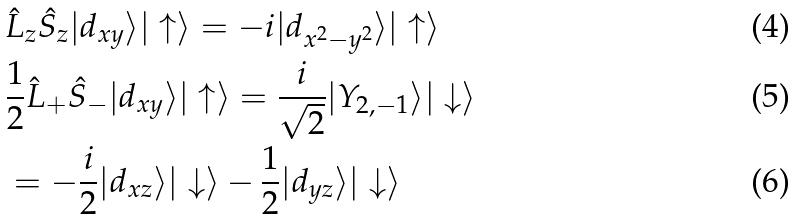<formula> <loc_0><loc_0><loc_500><loc_500>& \hat { L } _ { z } \hat { S } _ { z } | d _ { x y } \rangle | \uparrow \rangle = - i | d _ { x ^ { 2 } - y ^ { 2 } } \rangle | \uparrow \rangle \\ & \frac { 1 } { 2 } \hat { L } _ { + } \hat { S } _ { - } | d _ { x y } \rangle | \uparrow \rangle = \frac { i } { \sqrt { 2 } } | Y _ { 2 , - 1 } \rangle | \downarrow \rangle \\ & = - \frac { i } { 2 } | d _ { x z } \rangle | \downarrow \rangle - \frac { 1 } { 2 } | d _ { y z } \rangle | \downarrow \rangle</formula> 